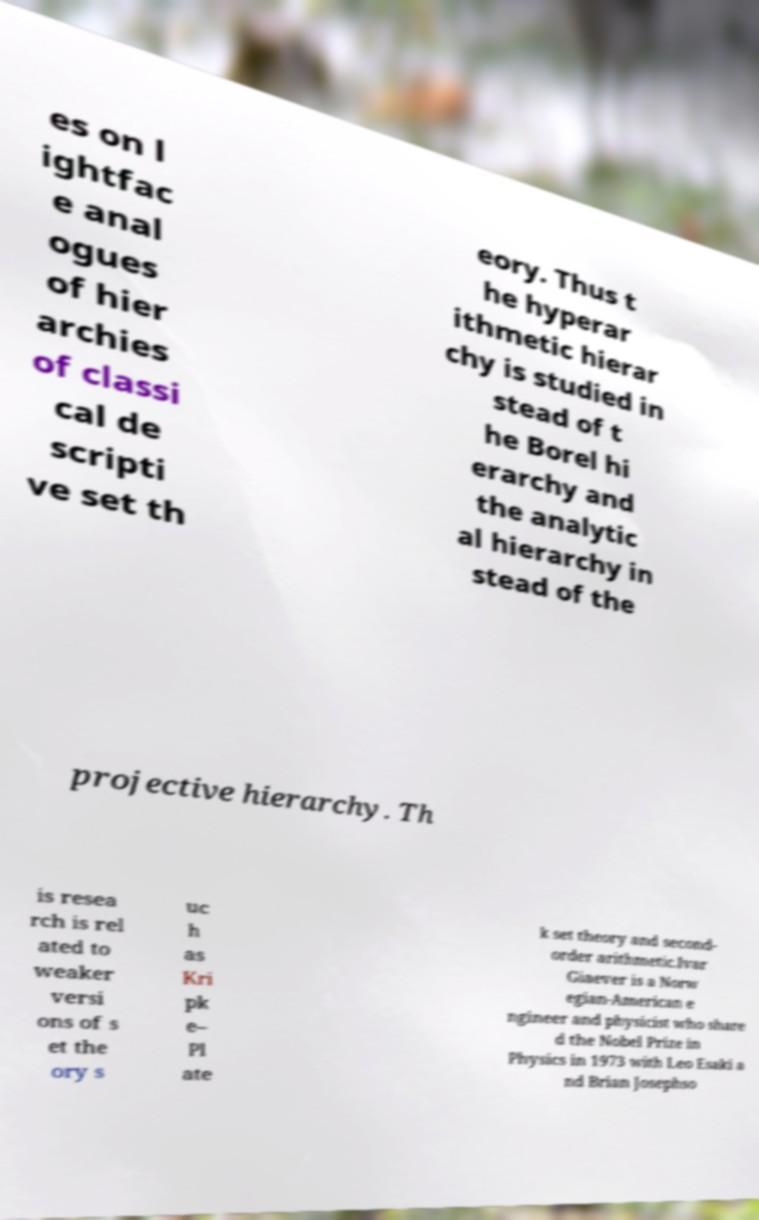For documentation purposes, I need the text within this image transcribed. Could you provide that? es on l ightfac e anal ogues of hier archies of classi cal de scripti ve set th eory. Thus t he hyperar ithmetic hierar chy is studied in stead of t he Borel hi erarchy and the analytic al hierarchy in stead of the projective hierarchy. Th is resea rch is rel ated to weaker versi ons of s et the ory s uc h as Kri pk e– Pl ate k set theory and second- order arithmetic.Ivar Giaever is a Norw egian-American e ngineer and physicist who share d the Nobel Prize in Physics in 1973 with Leo Esaki a nd Brian Josephso 